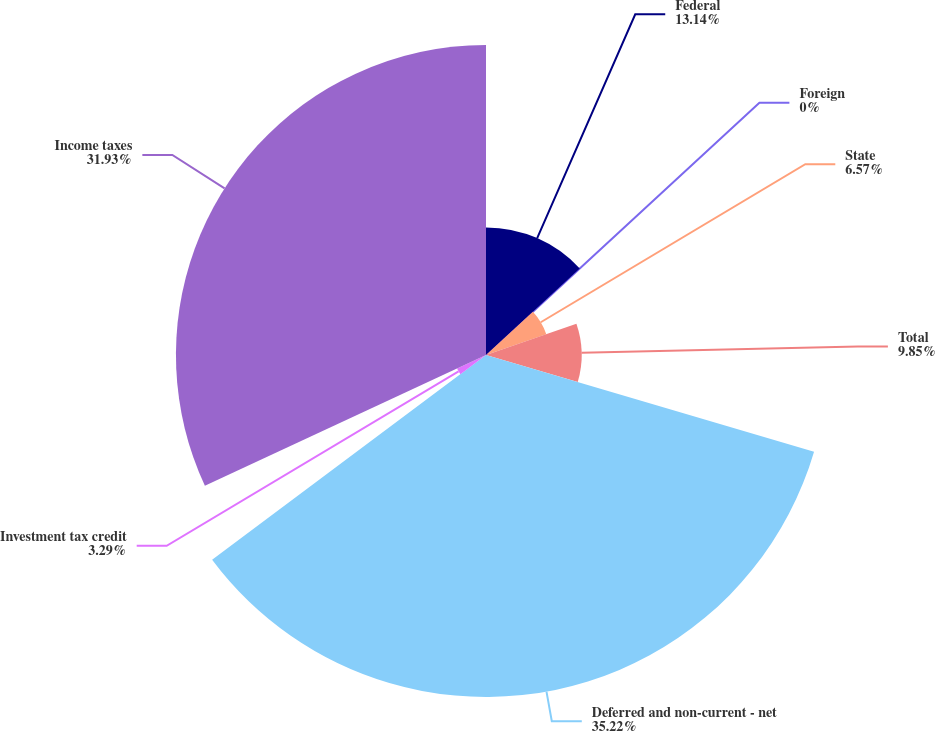<chart> <loc_0><loc_0><loc_500><loc_500><pie_chart><fcel>Federal<fcel>Foreign<fcel>State<fcel>Total<fcel>Deferred and non-current - net<fcel>Investment tax credit<fcel>Income taxes<nl><fcel>13.14%<fcel>0.0%<fcel>6.57%<fcel>9.85%<fcel>35.22%<fcel>3.29%<fcel>31.93%<nl></chart> 